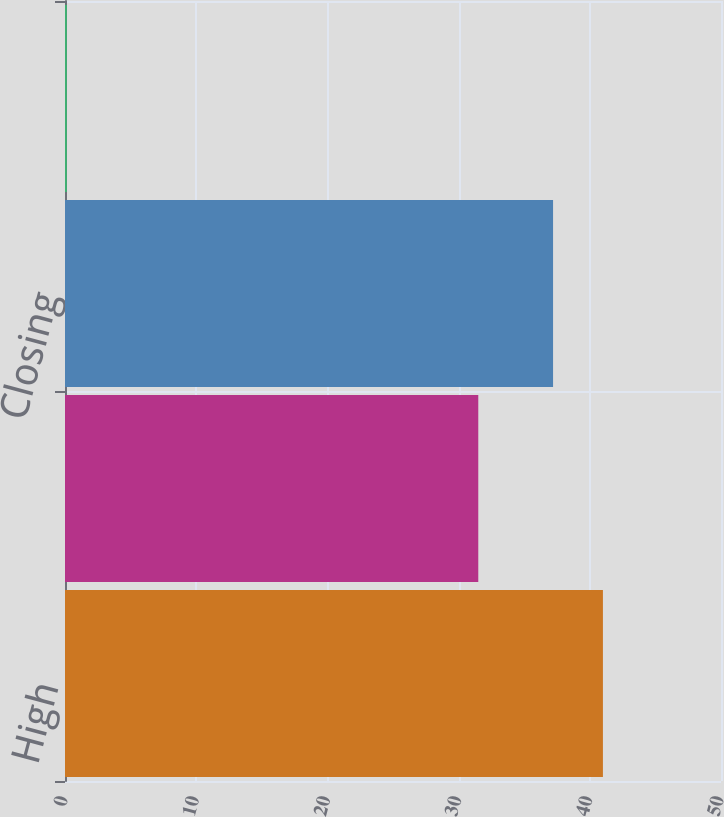Convert chart to OTSL. <chart><loc_0><loc_0><loc_500><loc_500><bar_chart><fcel>High<fcel>Low<fcel>Closing<fcel>Dividends Per Common Share<nl><fcel>41<fcel>31.5<fcel>37.2<fcel>0.14<nl></chart> 